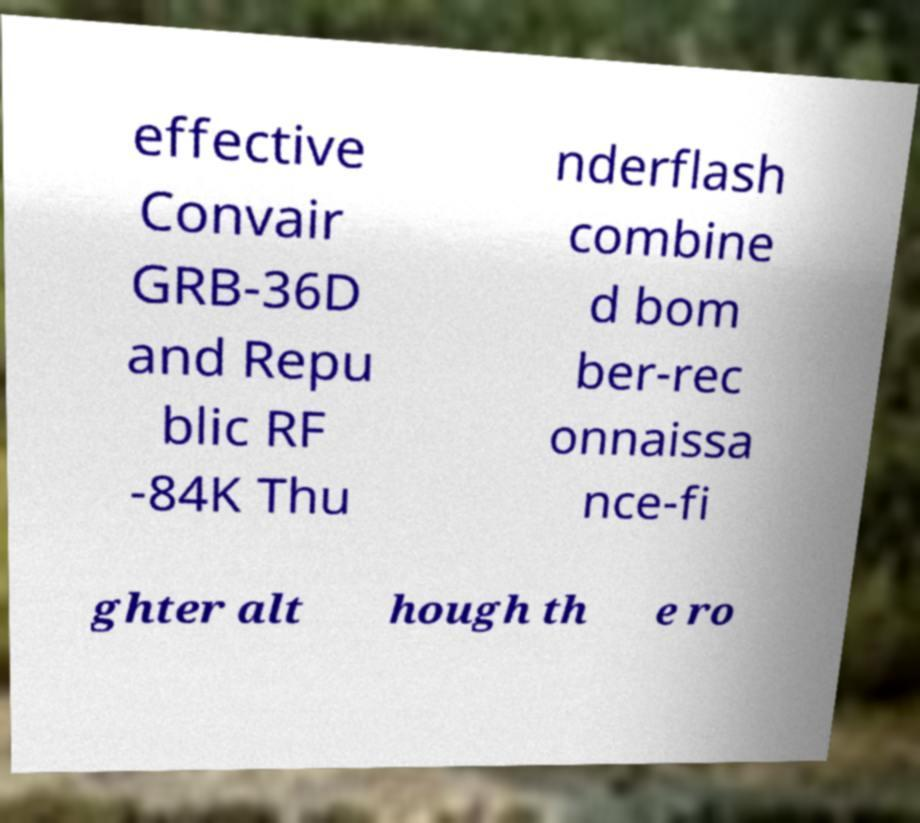Can you read and provide the text displayed in the image?This photo seems to have some interesting text. Can you extract and type it out for me? effective Convair GRB-36D and Repu blic RF -84K Thu nderflash combine d bom ber-rec onnaissa nce-fi ghter alt hough th e ro 